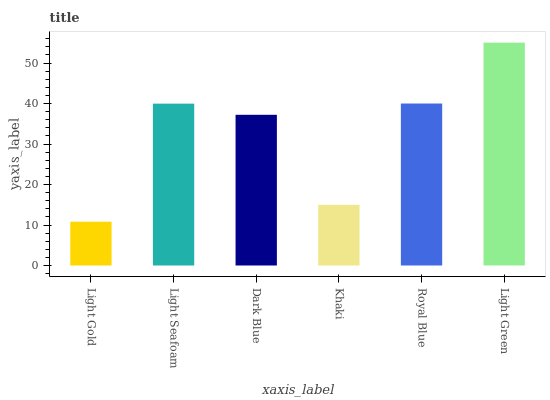Is Light Gold the minimum?
Answer yes or no. Yes. Is Light Green the maximum?
Answer yes or no. Yes. Is Light Seafoam the minimum?
Answer yes or no. No. Is Light Seafoam the maximum?
Answer yes or no. No. Is Light Seafoam greater than Light Gold?
Answer yes or no. Yes. Is Light Gold less than Light Seafoam?
Answer yes or no. Yes. Is Light Gold greater than Light Seafoam?
Answer yes or no. No. Is Light Seafoam less than Light Gold?
Answer yes or no. No. Is Light Seafoam the high median?
Answer yes or no. Yes. Is Dark Blue the low median?
Answer yes or no. Yes. Is Royal Blue the high median?
Answer yes or no. No. Is Royal Blue the low median?
Answer yes or no. No. 